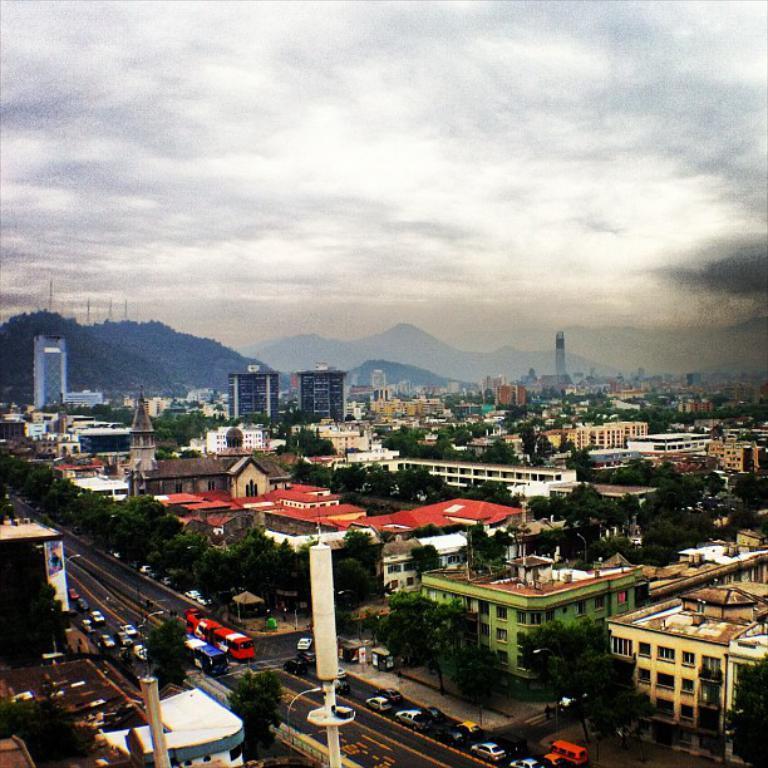Describe this image in one or two sentences. This image might be taken in the city. In this image we can see buildings, hills, trees, cars, roads, poles and vehicles. In the background there is sky and clouds. 